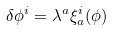Convert formula to latex. <formula><loc_0><loc_0><loc_500><loc_500>\delta \phi ^ { i } = \lambda ^ { a } \xi _ { a } ^ { i } ( \phi )</formula> 